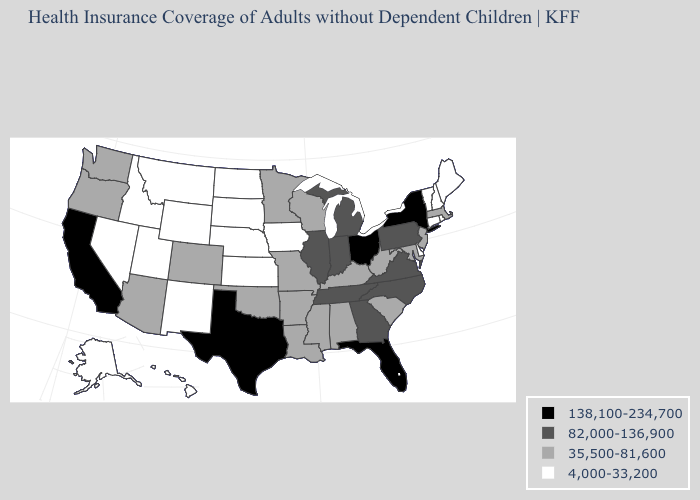What is the value of Arizona?
Short answer required. 35,500-81,600. Does the first symbol in the legend represent the smallest category?
Give a very brief answer. No. Name the states that have a value in the range 4,000-33,200?
Concise answer only. Alaska, Connecticut, Delaware, Hawaii, Idaho, Iowa, Kansas, Maine, Montana, Nebraska, Nevada, New Hampshire, New Mexico, North Dakota, Rhode Island, South Dakota, Utah, Vermont, Wyoming. Name the states that have a value in the range 82,000-136,900?
Concise answer only. Georgia, Illinois, Indiana, Michigan, North Carolina, Pennsylvania, Tennessee, Virginia. Name the states that have a value in the range 35,500-81,600?
Write a very short answer. Alabama, Arizona, Arkansas, Colorado, Kentucky, Louisiana, Maryland, Massachusetts, Minnesota, Mississippi, Missouri, New Jersey, Oklahoma, Oregon, South Carolina, Washington, West Virginia, Wisconsin. What is the highest value in the USA?
Answer briefly. 138,100-234,700. Name the states that have a value in the range 138,100-234,700?
Quick response, please. California, Florida, New York, Ohio, Texas. Does Illinois have a lower value than Connecticut?
Write a very short answer. No. What is the value of Indiana?
Write a very short answer. 82,000-136,900. Does Vermont have the lowest value in the USA?
Answer briefly. Yes. How many symbols are there in the legend?
Be succinct. 4. Name the states that have a value in the range 4,000-33,200?
Short answer required. Alaska, Connecticut, Delaware, Hawaii, Idaho, Iowa, Kansas, Maine, Montana, Nebraska, Nevada, New Hampshire, New Mexico, North Dakota, Rhode Island, South Dakota, Utah, Vermont, Wyoming. How many symbols are there in the legend?
Give a very brief answer. 4. Name the states that have a value in the range 82,000-136,900?
Write a very short answer. Georgia, Illinois, Indiana, Michigan, North Carolina, Pennsylvania, Tennessee, Virginia. Which states have the lowest value in the USA?
Keep it brief. Alaska, Connecticut, Delaware, Hawaii, Idaho, Iowa, Kansas, Maine, Montana, Nebraska, Nevada, New Hampshire, New Mexico, North Dakota, Rhode Island, South Dakota, Utah, Vermont, Wyoming. 